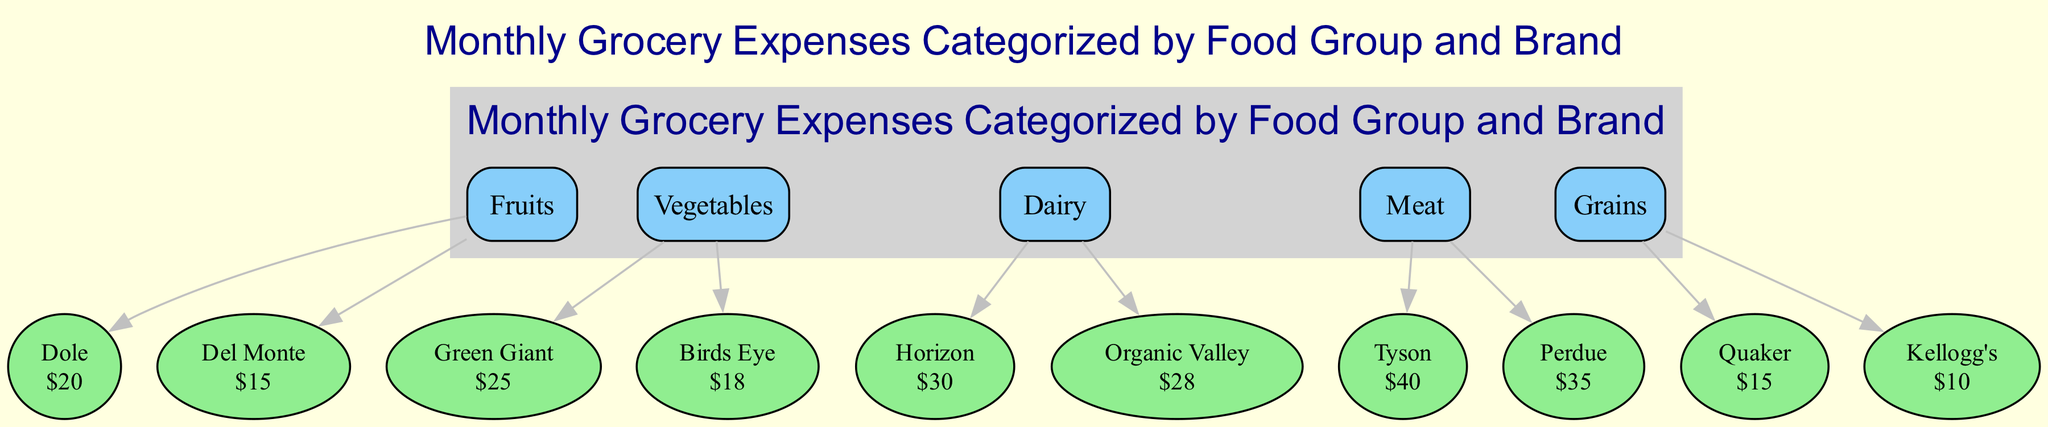What is the total expense for Fruits? The expenses for Fruits are Dole ($20) and Del Monte ($15). To find the total, we add these two amounts together: 20 + 15 = 35.
Answer: 35 Which brand has the highest expense in the Dairy category? In the Dairy category, the brands are Horizon ($30) and Organic Valley ($28). Horizon has the higher expense of the two, as $30 is greater than $28.
Answer: Horizon How many categories are included in the diagram? The diagram includes five categories: Fruits, Vegetables, Dairy, Meat, and Grains. By counting the listed categories, we find there are 5.
Answer: 5 What is the overall expense for Meat? The expenses for Meat are Tyson ($40) and Perdue ($35). Adding these amounts gives a total of 40 + 35 = 75.
Answer: 75 Which food group has the lowest total expense? The Grains category consists of Quaker ($15) and Kellogg's ($10). Adding them gives 15 + 10 = 25, which is lower than all other categories' totals.
Answer: Grains What is the expense for the Birds Eye brand? The only mentioned expense for Birds Eye is $18 under the Vegetables category. Therefore, the answer is simply the value given for Birds Eye.
Answer: 18 Which category contains the brand with the highest single expense? In the Meat category, Tyson has an expense of $40, which is higher than any expense in other categories. This means the Meat category contains the highest single expense.
Answer: Meat How many brands are there in the Vegetables category? The Vegetables category contains two brands: Green Giant and Birds Eye. Counting these gives us a total of 2 brands.
Answer: 2 Which food group has the highest combined expense? The Meat category, with Tyson ($40) and Perdue ($35), total to $75, which is the highest compared to total expenses in other categories.
Answer: Meat 